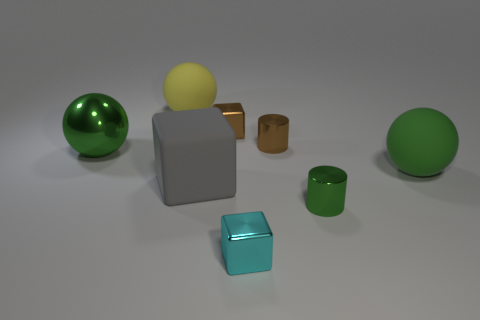How many objects are big red spheres or big gray matte objects?
Your answer should be compact. 1. What number of other things are there of the same size as the yellow rubber ball?
Give a very brief answer. 3. Does the matte block have the same color as the metal cylinder that is behind the matte block?
Offer a terse response. No. What number of cylinders are either big things or green metallic things?
Your response must be concise. 1. Are there any other things that are the same color as the rubber cube?
Provide a succinct answer. No. What is the material of the cube that is in front of the metal cylinder that is in front of the brown shiny cylinder?
Your answer should be compact. Metal. Are the cyan cube and the green ball that is on the left side of the gray matte object made of the same material?
Offer a very short reply. Yes. How many things are cubes in front of the green metal ball or big yellow spheres?
Provide a succinct answer. 3. Are there any big things that have the same color as the shiny sphere?
Your answer should be very brief. Yes. Do the big yellow matte object and the matte object on the right side of the tiny green shiny cylinder have the same shape?
Make the answer very short. Yes. 